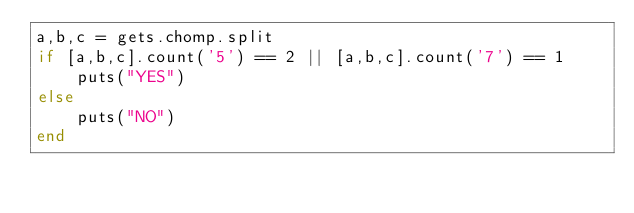<code> <loc_0><loc_0><loc_500><loc_500><_Ruby_>a,b,c = gets.chomp.split
if [a,b,c].count('5') == 2 || [a,b,c].count('7') == 1
    puts("YES")
else
    puts("NO")
end</code> 